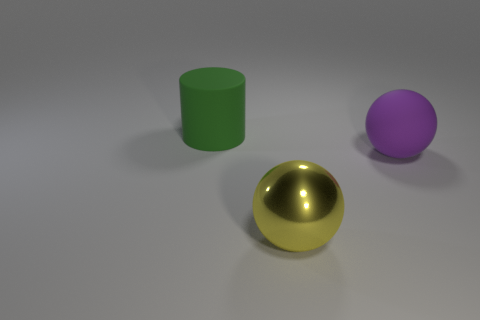Can you describe the texture of the objects shown? Certainly! The objects in the image have a smooth-looking texture, with the golden sphere having a reflective surface, while the purple sphere and green cylinder have a more matte finish. 